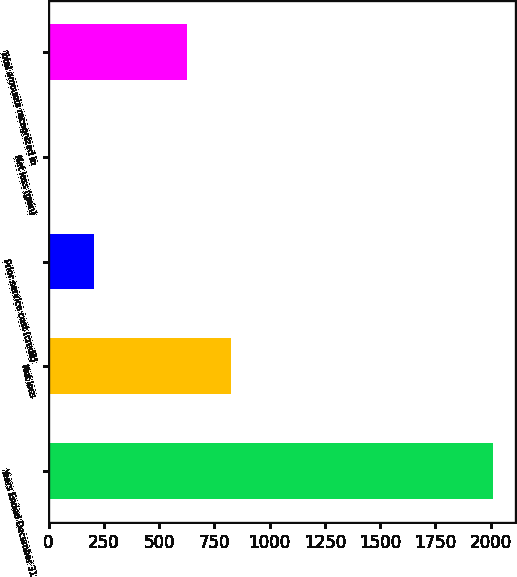Convert chart. <chart><loc_0><loc_0><loc_500><loc_500><bar_chart><fcel>Years Ended December 31<fcel>Net loss<fcel>Prior service cost (credit)<fcel>Net loss (gain)<fcel>Total amounts recognized in<nl><fcel>2011<fcel>826.6<fcel>205.6<fcel>5<fcel>626<nl></chart> 